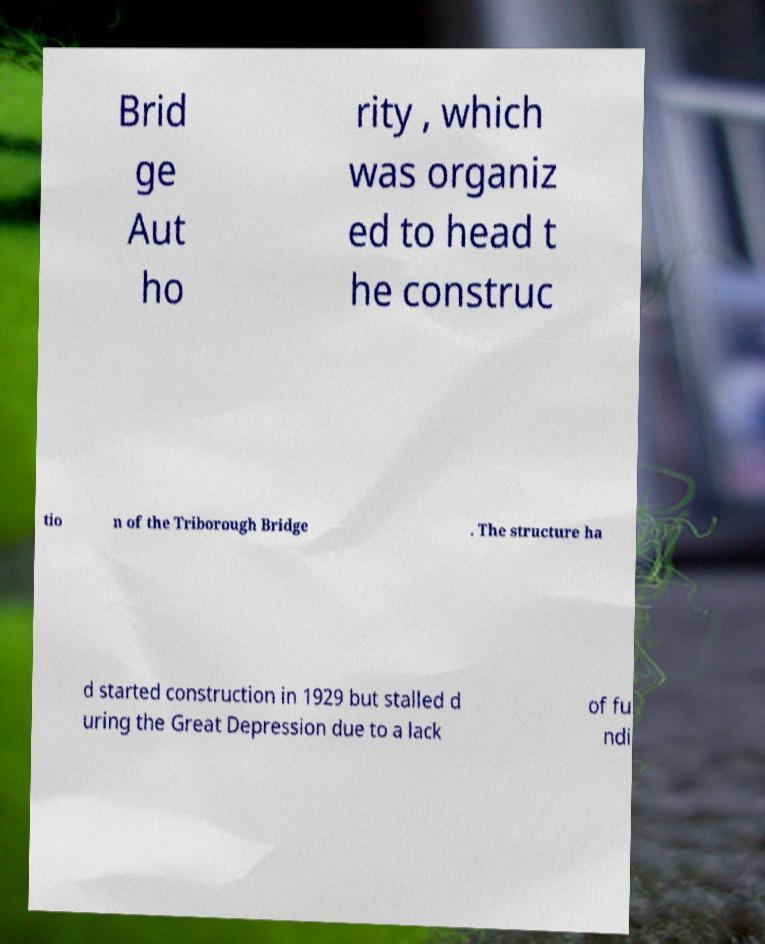I need the written content from this picture converted into text. Can you do that? Brid ge Aut ho rity , which was organiz ed to head t he construc tio n of the Triborough Bridge . The structure ha d started construction in 1929 but stalled d uring the Great Depression due to a lack of fu ndi 